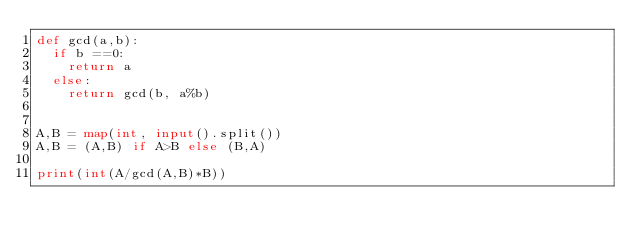<code> <loc_0><loc_0><loc_500><loc_500><_Python_>def gcd(a,b):
  if b ==0:
    return a
  else:
    return gcd(b, a%b)
  
  
A,B = map(int, input().split())
A,B = (A,B) if A>B else (B,A)

print(int(A/gcd(A,B)*B))</code> 